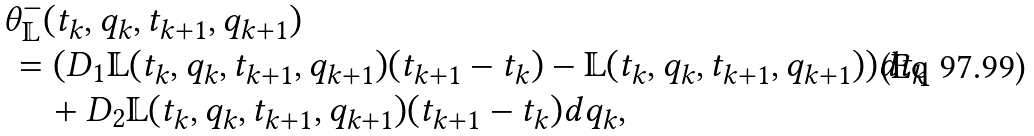Convert formula to latex. <formula><loc_0><loc_0><loc_500><loc_500>& \theta _ { \mathbb { L } } ^ { - } ( t _ { k } , q _ { k } , t _ { k + 1 } , q _ { k + 1 } ) \\ & \, = ( D _ { 1 } \mathbb { L } ( t _ { k } , q _ { k } , t _ { k + 1 } , q _ { k + 1 } ) ( t _ { k + 1 } - t _ { k } ) - \mathbb { L } ( t _ { k } , q _ { k } , t _ { k + 1 } , q _ { k + 1 } ) ) d t _ { k } \\ & \, \quad + D _ { 2 } \mathbb { L } ( t _ { k } , q _ { k } , t _ { k + 1 } , q _ { k + 1 } ) ( t _ { k + 1 } - t _ { k } ) d q _ { k } ,</formula> 